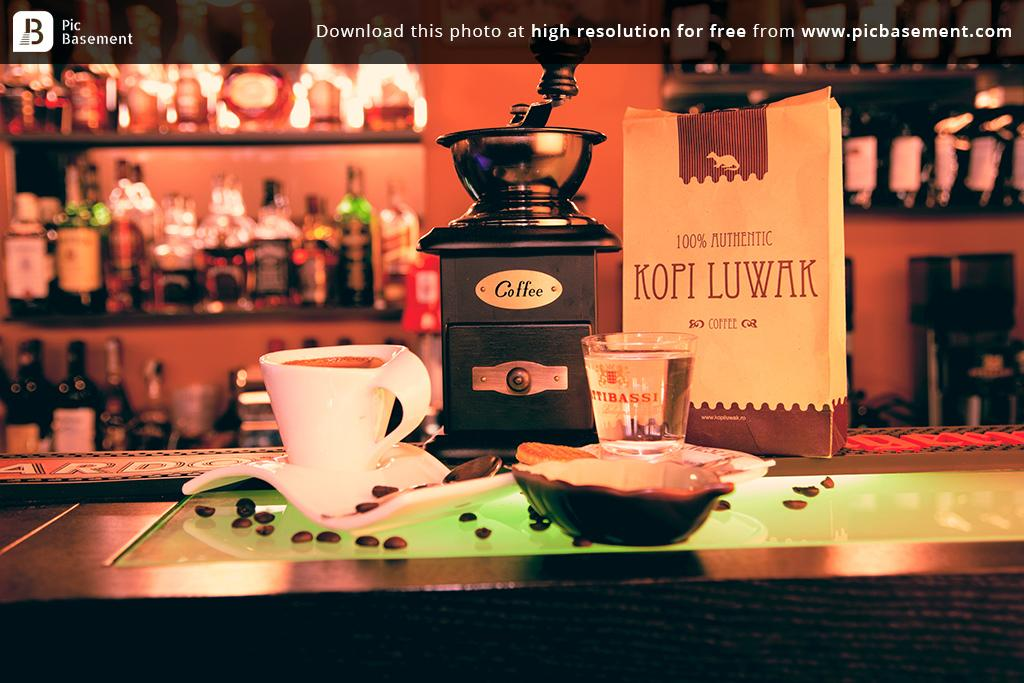<image>
Create a compact narrative representing the image presented. A bag of Kopi Luwak coffee on a table with a cup and beans 